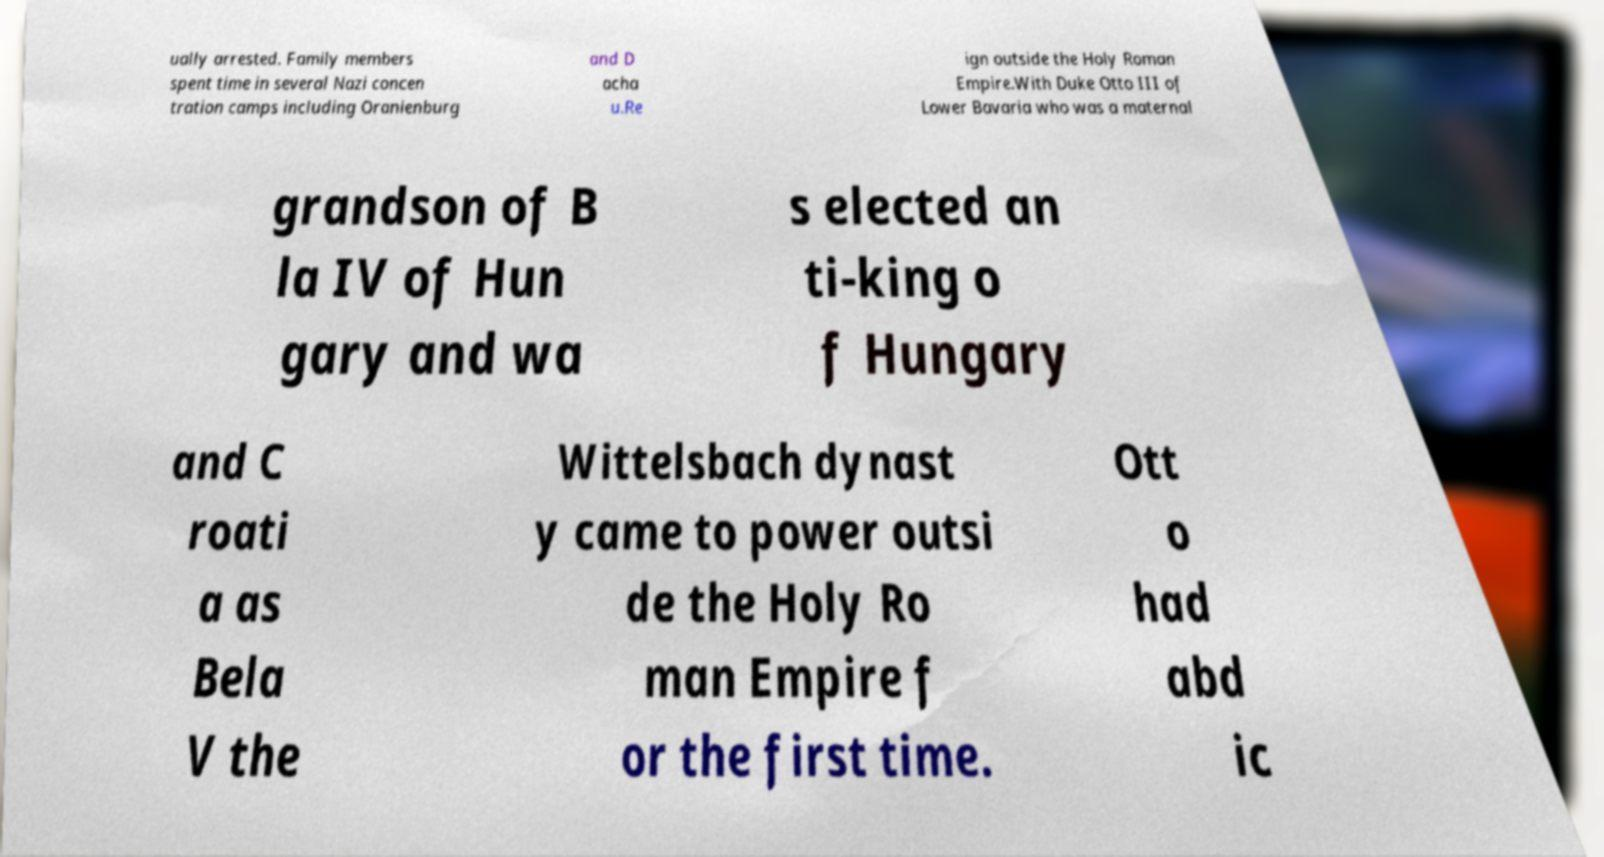Please read and relay the text visible in this image. What does it say? ually arrested. Family members spent time in several Nazi concen tration camps including Oranienburg and D acha u.Re ign outside the Holy Roman Empire.With Duke Otto III of Lower Bavaria who was a maternal grandson of B la IV of Hun gary and wa s elected an ti-king o f Hungary and C roati a as Bela V the Wittelsbach dynast y came to power outsi de the Holy Ro man Empire f or the first time. Ott o had abd ic 